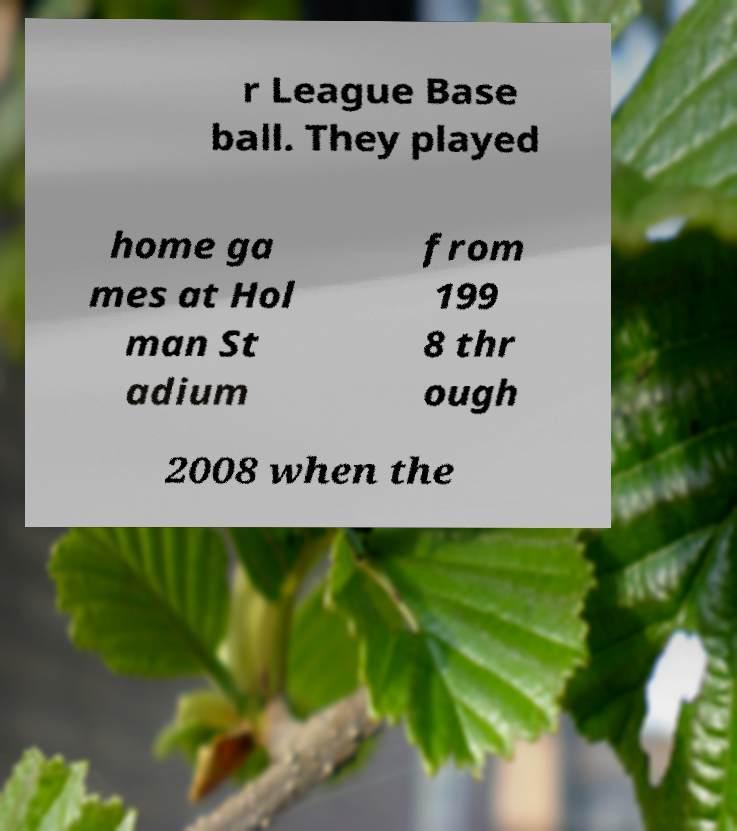I need the written content from this picture converted into text. Can you do that? r League Base ball. They played home ga mes at Hol man St adium from 199 8 thr ough 2008 when the 